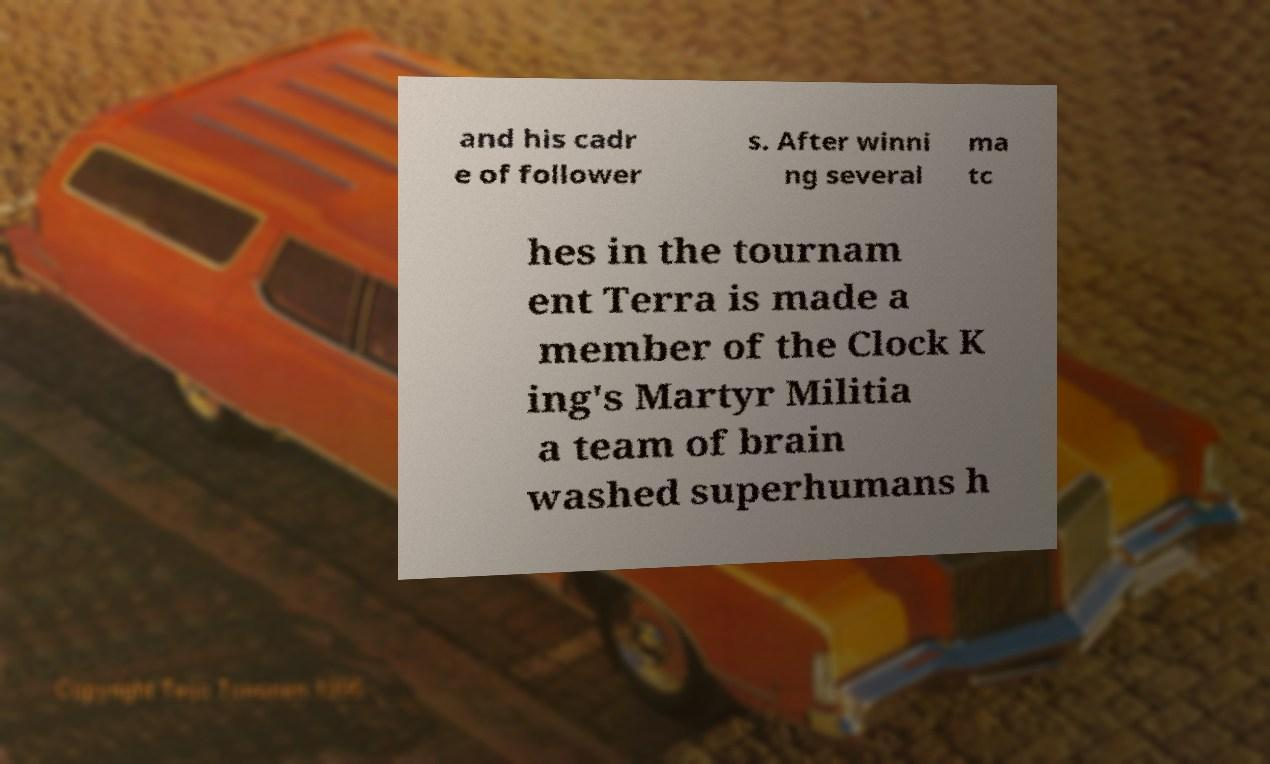Could you assist in decoding the text presented in this image and type it out clearly? and his cadr e of follower s. After winni ng several ma tc hes in the tournam ent Terra is made a member of the Clock K ing's Martyr Militia a team of brain washed superhumans h 